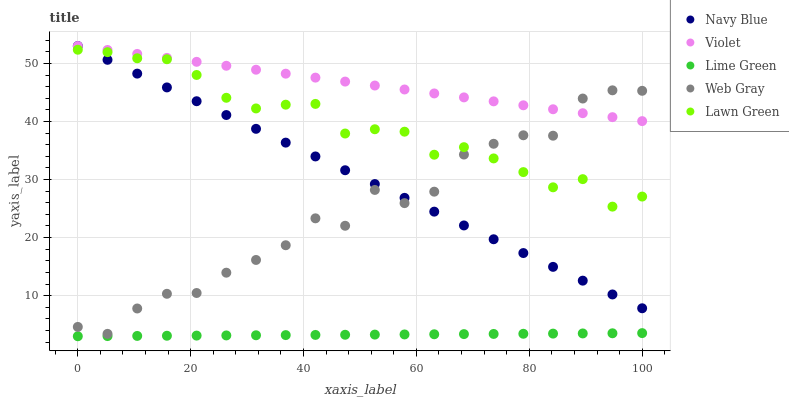Does Lime Green have the minimum area under the curve?
Answer yes or no. Yes. Does Violet have the maximum area under the curve?
Answer yes or no. Yes. Does Web Gray have the minimum area under the curve?
Answer yes or no. No. Does Web Gray have the maximum area under the curve?
Answer yes or no. No. Is Lime Green the smoothest?
Answer yes or no. Yes. Is Web Gray the roughest?
Answer yes or no. Yes. Is Web Gray the smoothest?
Answer yes or no. No. Is Lime Green the roughest?
Answer yes or no. No. Does Lime Green have the lowest value?
Answer yes or no. Yes. Does Web Gray have the lowest value?
Answer yes or no. No. Does Violet have the highest value?
Answer yes or no. Yes. Does Web Gray have the highest value?
Answer yes or no. No. Is Lime Green less than Navy Blue?
Answer yes or no. Yes. Is Violet greater than Lime Green?
Answer yes or no. Yes. Does Lawn Green intersect Navy Blue?
Answer yes or no. Yes. Is Lawn Green less than Navy Blue?
Answer yes or no. No. Is Lawn Green greater than Navy Blue?
Answer yes or no. No. Does Lime Green intersect Navy Blue?
Answer yes or no. No. 